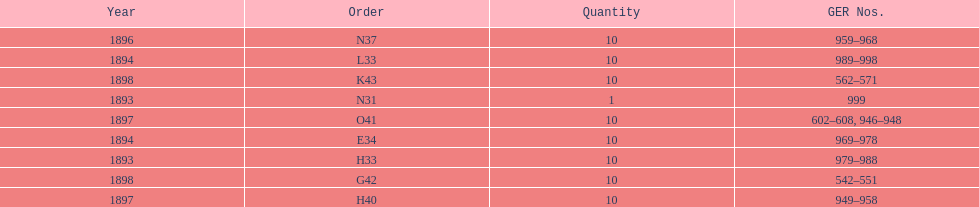How many years are listed? 5. 